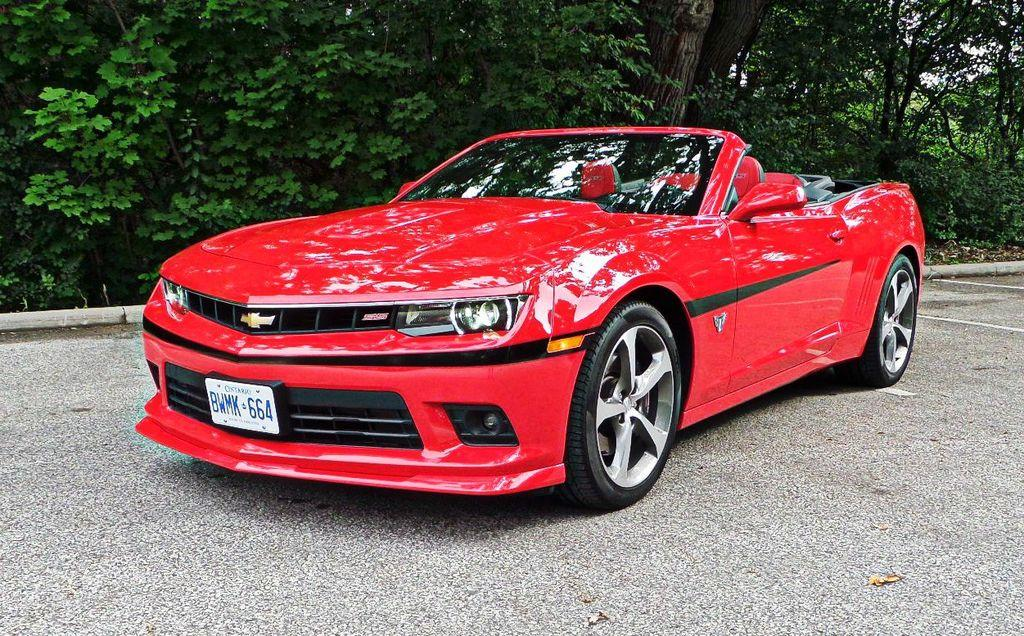What type of vehicle is in the image? There is a beautiful red color car in the image. Where is the car located? The car is in the road. What type of natural vegetation is visible in the image? There are trees visible in the back side of the image. What type of ice can be seen melting on the car's hood in the image? There is no ice visible on the car's hood in the image. What part of the brain is responsible for driving the car in the image? The image does not show any part of the brain; it features a car in the road. 